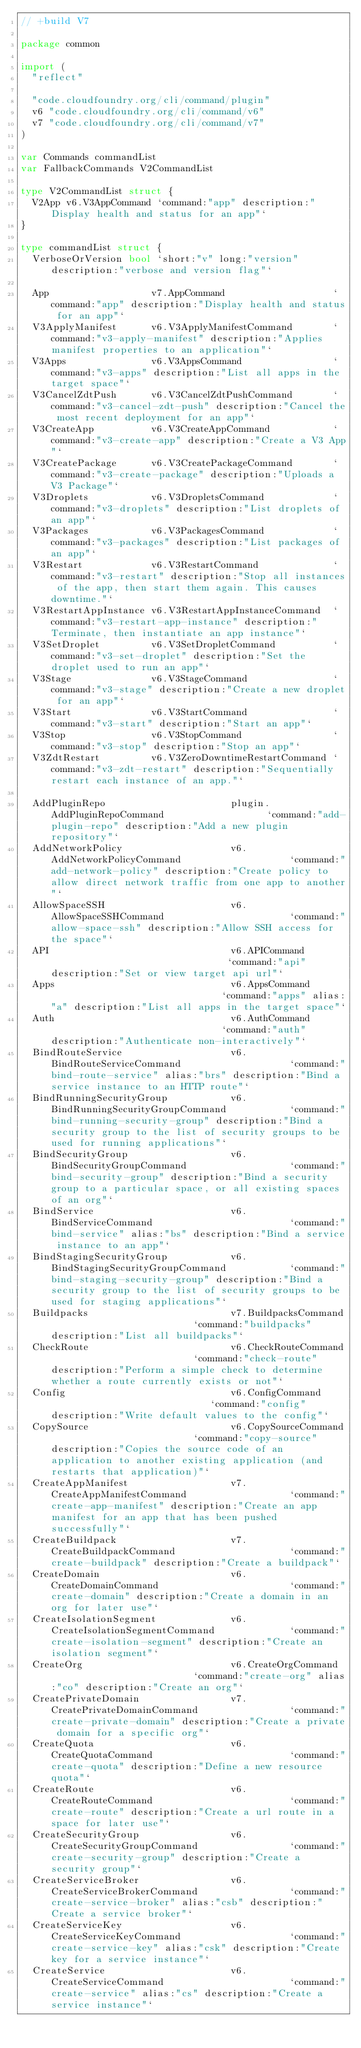Convert code to text. <code><loc_0><loc_0><loc_500><loc_500><_Go_>// +build V7

package common

import (
	"reflect"

	"code.cloudfoundry.org/cli/command/plugin"
	v6 "code.cloudfoundry.org/cli/command/v6"
	v7 "code.cloudfoundry.org/cli/command/v7"
)

var Commands commandList
var FallbackCommands V2CommandList

type V2CommandList struct {
	V2App v6.V3AppCommand `command:"app" description:"Display health and status for an app"`
}

type commandList struct {
	VerboseOrVersion bool `short:"v" long:"version" description:"verbose and version flag"`

	App                  v7.AppCommand                   `command:"app" description:"Display health and status for an app"`
	V3ApplyManifest      v6.V3ApplyManifestCommand       `command:"v3-apply-manifest" description:"Applies manifest properties to an application"`
	V3Apps               v6.V3AppsCommand                `command:"v3-apps" description:"List all apps in the target space"`
	V3CancelZdtPush      v6.V3CancelZdtPushCommand       `command:"v3-cancel-zdt-push" description:"Cancel the most recent deployment for an app"`
	V3CreateApp          v6.V3CreateAppCommand           `command:"v3-create-app" description:"Create a V3 App"`
	V3CreatePackage      v6.V3CreatePackageCommand       `command:"v3-create-package" description:"Uploads a V3 Package"`
	V3Droplets           v6.V3DropletsCommand            `command:"v3-droplets" description:"List droplets of an app"`
	V3Packages           v6.V3PackagesCommand            `command:"v3-packages" description:"List packages of an app"`
	V3Restart            v6.V3RestartCommand             `command:"v3-restart" description:"Stop all instances of the app, then start them again. This causes downtime."`
	V3RestartAppInstance v6.V3RestartAppInstanceCommand  `command:"v3-restart-app-instance" description:"Terminate, then instantiate an app instance"`
	V3SetDroplet         v6.V3SetDropletCommand          `command:"v3-set-droplet" description:"Set the droplet used to run an app"`
	V3Stage              v6.V3StageCommand               `command:"v3-stage" description:"Create a new droplet for an app"`
	V3Start              v6.V3StartCommand               `command:"v3-start" description:"Start an app"`
	V3Stop               v6.V3StopCommand                `command:"v3-stop" description:"Stop an app"`
	V3ZdtRestart         v6.V3ZeroDowntimeRestartCommand `command:"v3-zdt-restart" description:"Sequentially restart each instance of an app."`

	AddPluginRepo                      plugin.AddPluginRepoCommand                  `command:"add-plugin-repo" description:"Add a new plugin repository"`
	AddNetworkPolicy                   v6.AddNetworkPolicyCommand                   `command:"add-network-policy" description:"Create policy to allow direct network traffic from one app to another"`
	AllowSpaceSSH                      v6.AllowSpaceSSHCommand                      `command:"allow-space-ssh" description:"Allow SSH access for the space"`
	API                                v6.APICommand                                `command:"api" description:"Set or view target api url"`
	Apps                               v6.AppsCommand                               `command:"apps" alias:"a" description:"List all apps in the target space"`
	Auth                               v6.AuthCommand                               `command:"auth" description:"Authenticate non-interactively"`
	BindRouteService                   v6.BindRouteServiceCommand                   `command:"bind-route-service" alias:"brs" description:"Bind a service instance to an HTTP route"`
	BindRunningSecurityGroup           v6.BindRunningSecurityGroupCommand           `command:"bind-running-security-group" description:"Bind a security group to the list of security groups to be used for running applications"`
	BindSecurityGroup                  v6.BindSecurityGroupCommand                  `command:"bind-security-group" description:"Bind a security group to a particular space, or all existing spaces of an org"`
	BindService                        v6.BindServiceCommand                        `command:"bind-service" alias:"bs" description:"Bind a service instance to an app"`
	BindStagingSecurityGroup           v6.BindStagingSecurityGroupCommand           `command:"bind-staging-security-group" description:"Bind a security group to the list of security groups to be used for staging applications"`
	Buildpacks                         v7.BuildpacksCommand                         `command:"buildpacks" description:"List all buildpacks"`
	CheckRoute                         v6.CheckRouteCommand                         `command:"check-route" description:"Perform a simple check to determine whether a route currently exists or not"`
	Config                             v6.ConfigCommand                             `command:"config" description:"Write default values to the config"`
	CopySource                         v6.CopySourceCommand                         `command:"copy-source" description:"Copies the source code of an application to another existing application (and restarts that application)"`
	CreateAppManifest                  v7.CreateAppManifestCommand                  `command:"create-app-manifest" description:"Create an app manifest for an app that has been pushed successfully"`
	CreateBuildpack                    v7.CreateBuildpackCommand                    `command:"create-buildpack" description:"Create a buildpack"`
	CreateDomain                       v6.CreateDomainCommand                       `command:"create-domain" description:"Create a domain in an org for later use"`
	CreateIsolationSegment             v6.CreateIsolationSegmentCommand             `command:"create-isolation-segment" description:"Create an isolation segment"`
	CreateOrg                          v6.CreateOrgCommand                          `command:"create-org" alias:"co" description:"Create an org"`
	CreatePrivateDomain                v7.CreatePrivateDomainCommand                `command:"create-private-domain" description:"Create a private domain for a specific org"`
	CreateQuota                        v6.CreateQuotaCommand                        `command:"create-quota" description:"Define a new resource quota"`
	CreateRoute                        v6.CreateRouteCommand                        `command:"create-route" description:"Create a url route in a space for later use"`
	CreateSecurityGroup                v6.CreateSecurityGroupCommand                `command:"create-security-group" description:"Create a security group"`
	CreateServiceBroker                v6.CreateServiceBrokerCommand                `command:"create-service-broker" alias:"csb" description:"Create a service broker"`
	CreateServiceKey                   v6.CreateServiceKeyCommand                   `command:"create-service-key" alias:"csk" description:"Create key for a service instance"`
	CreateService                      v6.CreateServiceCommand                      `command:"create-service" alias:"cs" description:"Create a service instance"`</code> 